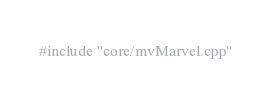Convert code to text. <code><loc_0><loc_0><loc_500><loc_500><_ObjectiveC_>#include "core/mvMarvel.cpp"</code> 